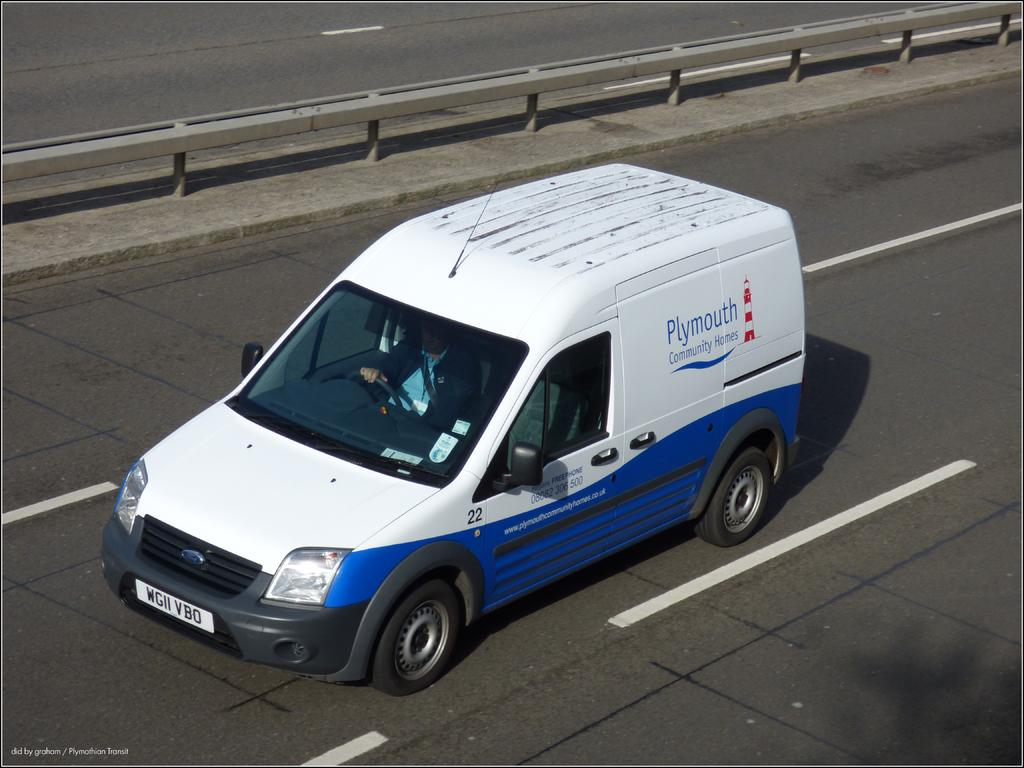What color is the car in the image? The car in the image is white. What is the car doing in the image? The car is moving on a road. What can be seen separating the lanes on the road? There is a divider visible in the image. What type of wood can be seen being printed in the image? There is no wood or printing process present in the image; it features a white color car moving on a road with a divider. 